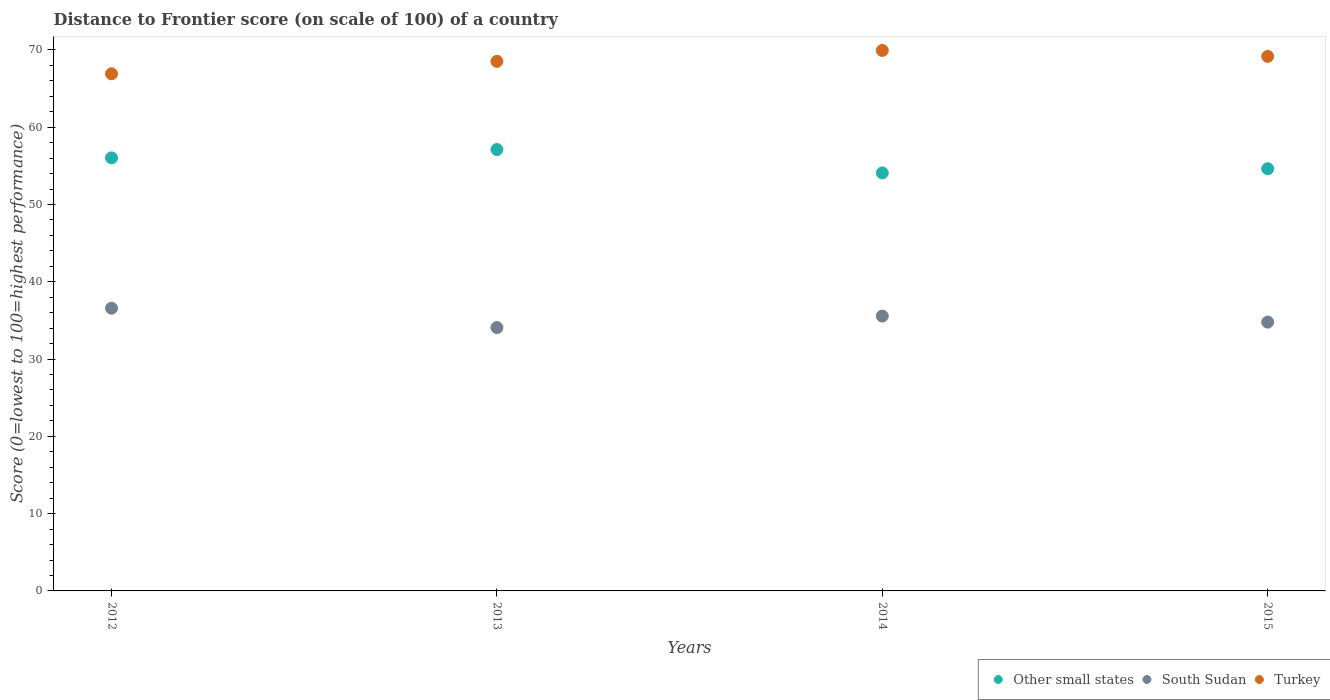How many different coloured dotlines are there?
Offer a very short reply. 3. What is the distance to frontier score of in Turkey in 2013?
Offer a very short reply. 68.52. Across all years, what is the maximum distance to frontier score of in South Sudan?
Your answer should be very brief. 36.58. Across all years, what is the minimum distance to frontier score of in South Sudan?
Your answer should be very brief. 34.07. In which year was the distance to frontier score of in South Sudan maximum?
Offer a terse response. 2012. In which year was the distance to frontier score of in Turkey minimum?
Provide a short and direct response. 2012. What is the total distance to frontier score of in South Sudan in the graph?
Give a very brief answer. 140.99. What is the difference between the distance to frontier score of in South Sudan in 2012 and that in 2014?
Give a very brief answer. 1.02. What is the difference between the distance to frontier score of in Turkey in 2015 and the distance to frontier score of in Other small states in 2014?
Make the answer very short. 15.08. What is the average distance to frontier score of in Other small states per year?
Ensure brevity in your answer.  55.46. In the year 2015, what is the difference between the distance to frontier score of in South Sudan and distance to frontier score of in Turkey?
Give a very brief answer. -34.38. In how many years, is the distance to frontier score of in Other small states greater than 52?
Your response must be concise. 4. What is the ratio of the distance to frontier score of in South Sudan in 2012 to that in 2013?
Offer a terse response. 1.07. Is the distance to frontier score of in South Sudan in 2013 less than that in 2014?
Your answer should be very brief. Yes. Is the difference between the distance to frontier score of in South Sudan in 2012 and 2014 greater than the difference between the distance to frontier score of in Turkey in 2012 and 2014?
Offer a terse response. Yes. What is the difference between the highest and the second highest distance to frontier score of in South Sudan?
Your answer should be compact. 1.02. What is the difference between the highest and the lowest distance to frontier score of in South Sudan?
Offer a terse response. 2.51. In how many years, is the distance to frontier score of in South Sudan greater than the average distance to frontier score of in South Sudan taken over all years?
Keep it short and to the point. 2. Is it the case that in every year, the sum of the distance to frontier score of in South Sudan and distance to frontier score of in Turkey  is greater than the distance to frontier score of in Other small states?
Keep it short and to the point. Yes. Is the distance to frontier score of in Other small states strictly less than the distance to frontier score of in South Sudan over the years?
Provide a succinct answer. No. How many dotlines are there?
Make the answer very short. 3. Does the graph contain any zero values?
Offer a terse response. No. Does the graph contain grids?
Make the answer very short. No. Where does the legend appear in the graph?
Provide a short and direct response. Bottom right. What is the title of the graph?
Provide a short and direct response. Distance to Frontier score (on scale of 100) of a country. What is the label or title of the X-axis?
Provide a succinct answer. Years. What is the label or title of the Y-axis?
Give a very brief answer. Score (0=lowest to 100=highest performance). What is the Score (0=lowest to 100=highest performance) in Other small states in 2012?
Provide a succinct answer. 56.03. What is the Score (0=lowest to 100=highest performance) in South Sudan in 2012?
Offer a terse response. 36.58. What is the Score (0=lowest to 100=highest performance) in Turkey in 2012?
Provide a succinct answer. 66.91. What is the Score (0=lowest to 100=highest performance) in Other small states in 2013?
Offer a terse response. 57.11. What is the Score (0=lowest to 100=highest performance) in South Sudan in 2013?
Give a very brief answer. 34.07. What is the Score (0=lowest to 100=highest performance) of Turkey in 2013?
Provide a short and direct response. 68.52. What is the Score (0=lowest to 100=highest performance) of Other small states in 2014?
Give a very brief answer. 54.08. What is the Score (0=lowest to 100=highest performance) of South Sudan in 2014?
Your response must be concise. 35.56. What is the Score (0=lowest to 100=highest performance) of Turkey in 2014?
Your answer should be very brief. 69.93. What is the Score (0=lowest to 100=highest performance) in Other small states in 2015?
Offer a terse response. 54.62. What is the Score (0=lowest to 100=highest performance) of South Sudan in 2015?
Offer a terse response. 34.78. What is the Score (0=lowest to 100=highest performance) in Turkey in 2015?
Your answer should be compact. 69.16. Across all years, what is the maximum Score (0=lowest to 100=highest performance) in Other small states?
Provide a succinct answer. 57.11. Across all years, what is the maximum Score (0=lowest to 100=highest performance) of South Sudan?
Your answer should be very brief. 36.58. Across all years, what is the maximum Score (0=lowest to 100=highest performance) of Turkey?
Keep it short and to the point. 69.93. Across all years, what is the minimum Score (0=lowest to 100=highest performance) in Other small states?
Keep it short and to the point. 54.08. Across all years, what is the minimum Score (0=lowest to 100=highest performance) in South Sudan?
Ensure brevity in your answer.  34.07. Across all years, what is the minimum Score (0=lowest to 100=highest performance) in Turkey?
Make the answer very short. 66.91. What is the total Score (0=lowest to 100=highest performance) in Other small states in the graph?
Provide a short and direct response. 221.85. What is the total Score (0=lowest to 100=highest performance) of South Sudan in the graph?
Your answer should be compact. 140.99. What is the total Score (0=lowest to 100=highest performance) of Turkey in the graph?
Offer a very short reply. 274.52. What is the difference between the Score (0=lowest to 100=highest performance) in Other small states in 2012 and that in 2013?
Provide a succinct answer. -1.08. What is the difference between the Score (0=lowest to 100=highest performance) of South Sudan in 2012 and that in 2013?
Ensure brevity in your answer.  2.51. What is the difference between the Score (0=lowest to 100=highest performance) of Turkey in 2012 and that in 2013?
Offer a very short reply. -1.61. What is the difference between the Score (0=lowest to 100=highest performance) of Other small states in 2012 and that in 2014?
Offer a terse response. 1.95. What is the difference between the Score (0=lowest to 100=highest performance) of Turkey in 2012 and that in 2014?
Provide a short and direct response. -3.02. What is the difference between the Score (0=lowest to 100=highest performance) of Other small states in 2012 and that in 2015?
Offer a terse response. 1.41. What is the difference between the Score (0=lowest to 100=highest performance) of South Sudan in 2012 and that in 2015?
Offer a very short reply. 1.8. What is the difference between the Score (0=lowest to 100=highest performance) in Turkey in 2012 and that in 2015?
Offer a terse response. -2.25. What is the difference between the Score (0=lowest to 100=highest performance) in Other small states in 2013 and that in 2014?
Make the answer very short. 3.03. What is the difference between the Score (0=lowest to 100=highest performance) in South Sudan in 2013 and that in 2014?
Make the answer very short. -1.49. What is the difference between the Score (0=lowest to 100=highest performance) of Turkey in 2013 and that in 2014?
Your answer should be very brief. -1.41. What is the difference between the Score (0=lowest to 100=highest performance) of Other small states in 2013 and that in 2015?
Ensure brevity in your answer.  2.49. What is the difference between the Score (0=lowest to 100=highest performance) of South Sudan in 2013 and that in 2015?
Make the answer very short. -0.71. What is the difference between the Score (0=lowest to 100=highest performance) in Turkey in 2013 and that in 2015?
Offer a terse response. -0.64. What is the difference between the Score (0=lowest to 100=highest performance) of Other small states in 2014 and that in 2015?
Provide a succinct answer. -0.54. What is the difference between the Score (0=lowest to 100=highest performance) of South Sudan in 2014 and that in 2015?
Offer a very short reply. 0.78. What is the difference between the Score (0=lowest to 100=highest performance) of Turkey in 2014 and that in 2015?
Offer a very short reply. 0.77. What is the difference between the Score (0=lowest to 100=highest performance) of Other small states in 2012 and the Score (0=lowest to 100=highest performance) of South Sudan in 2013?
Ensure brevity in your answer.  21.96. What is the difference between the Score (0=lowest to 100=highest performance) in Other small states in 2012 and the Score (0=lowest to 100=highest performance) in Turkey in 2013?
Provide a succinct answer. -12.49. What is the difference between the Score (0=lowest to 100=highest performance) in South Sudan in 2012 and the Score (0=lowest to 100=highest performance) in Turkey in 2013?
Provide a short and direct response. -31.94. What is the difference between the Score (0=lowest to 100=highest performance) in Other small states in 2012 and the Score (0=lowest to 100=highest performance) in South Sudan in 2014?
Provide a succinct answer. 20.47. What is the difference between the Score (0=lowest to 100=highest performance) of Other small states in 2012 and the Score (0=lowest to 100=highest performance) of Turkey in 2014?
Provide a short and direct response. -13.9. What is the difference between the Score (0=lowest to 100=highest performance) in South Sudan in 2012 and the Score (0=lowest to 100=highest performance) in Turkey in 2014?
Offer a very short reply. -33.35. What is the difference between the Score (0=lowest to 100=highest performance) in Other small states in 2012 and the Score (0=lowest to 100=highest performance) in South Sudan in 2015?
Keep it short and to the point. 21.25. What is the difference between the Score (0=lowest to 100=highest performance) in Other small states in 2012 and the Score (0=lowest to 100=highest performance) in Turkey in 2015?
Ensure brevity in your answer.  -13.13. What is the difference between the Score (0=lowest to 100=highest performance) of South Sudan in 2012 and the Score (0=lowest to 100=highest performance) of Turkey in 2015?
Ensure brevity in your answer.  -32.58. What is the difference between the Score (0=lowest to 100=highest performance) in Other small states in 2013 and the Score (0=lowest to 100=highest performance) in South Sudan in 2014?
Make the answer very short. 21.55. What is the difference between the Score (0=lowest to 100=highest performance) of Other small states in 2013 and the Score (0=lowest to 100=highest performance) of Turkey in 2014?
Provide a short and direct response. -12.82. What is the difference between the Score (0=lowest to 100=highest performance) of South Sudan in 2013 and the Score (0=lowest to 100=highest performance) of Turkey in 2014?
Ensure brevity in your answer.  -35.86. What is the difference between the Score (0=lowest to 100=highest performance) in Other small states in 2013 and the Score (0=lowest to 100=highest performance) in South Sudan in 2015?
Provide a succinct answer. 22.33. What is the difference between the Score (0=lowest to 100=highest performance) in Other small states in 2013 and the Score (0=lowest to 100=highest performance) in Turkey in 2015?
Your answer should be very brief. -12.05. What is the difference between the Score (0=lowest to 100=highest performance) in South Sudan in 2013 and the Score (0=lowest to 100=highest performance) in Turkey in 2015?
Make the answer very short. -35.09. What is the difference between the Score (0=lowest to 100=highest performance) of Other small states in 2014 and the Score (0=lowest to 100=highest performance) of South Sudan in 2015?
Provide a short and direct response. 19.3. What is the difference between the Score (0=lowest to 100=highest performance) of Other small states in 2014 and the Score (0=lowest to 100=highest performance) of Turkey in 2015?
Give a very brief answer. -15.08. What is the difference between the Score (0=lowest to 100=highest performance) of South Sudan in 2014 and the Score (0=lowest to 100=highest performance) of Turkey in 2015?
Offer a terse response. -33.6. What is the average Score (0=lowest to 100=highest performance) in Other small states per year?
Offer a very short reply. 55.46. What is the average Score (0=lowest to 100=highest performance) of South Sudan per year?
Offer a terse response. 35.25. What is the average Score (0=lowest to 100=highest performance) in Turkey per year?
Provide a succinct answer. 68.63. In the year 2012, what is the difference between the Score (0=lowest to 100=highest performance) in Other small states and Score (0=lowest to 100=highest performance) in South Sudan?
Keep it short and to the point. 19.45. In the year 2012, what is the difference between the Score (0=lowest to 100=highest performance) of Other small states and Score (0=lowest to 100=highest performance) of Turkey?
Your answer should be compact. -10.88. In the year 2012, what is the difference between the Score (0=lowest to 100=highest performance) of South Sudan and Score (0=lowest to 100=highest performance) of Turkey?
Your answer should be very brief. -30.33. In the year 2013, what is the difference between the Score (0=lowest to 100=highest performance) in Other small states and Score (0=lowest to 100=highest performance) in South Sudan?
Offer a terse response. 23.04. In the year 2013, what is the difference between the Score (0=lowest to 100=highest performance) in Other small states and Score (0=lowest to 100=highest performance) in Turkey?
Keep it short and to the point. -11.41. In the year 2013, what is the difference between the Score (0=lowest to 100=highest performance) of South Sudan and Score (0=lowest to 100=highest performance) of Turkey?
Your answer should be very brief. -34.45. In the year 2014, what is the difference between the Score (0=lowest to 100=highest performance) in Other small states and Score (0=lowest to 100=highest performance) in South Sudan?
Provide a succinct answer. 18.52. In the year 2014, what is the difference between the Score (0=lowest to 100=highest performance) in Other small states and Score (0=lowest to 100=highest performance) in Turkey?
Your response must be concise. -15.85. In the year 2014, what is the difference between the Score (0=lowest to 100=highest performance) in South Sudan and Score (0=lowest to 100=highest performance) in Turkey?
Keep it short and to the point. -34.37. In the year 2015, what is the difference between the Score (0=lowest to 100=highest performance) of Other small states and Score (0=lowest to 100=highest performance) of South Sudan?
Your answer should be compact. 19.84. In the year 2015, what is the difference between the Score (0=lowest to 100=highest performance) of Other small states and Score (0=lowest to 100=highest performance) of Turkey?
Offer a terse response. -14.54. In the year 2015, what is the difference between the Score (0=lowest to 100=highest performance) of South Sudan and Score (0=lowest to 100=highest performance) of Turkey?
Make the answer very short. -34.38. What is the ratio of the Score (0=lowest to 100=highest performance) of Other small states in 2012 to that in 2013?
Keep it short and to the point. 0.98. What is the ratio of the Score (0=lowest to 100=highest performance) in South Sudan in 2012 to that in 2013?
Offer a terse response. 1.07. What is the ratio of the Score (0=lowest to 100=highest performance) in Turkey in 2012 to that in 2013?
Provide a short and direct response. 0.98. What is the ratio of the Score (0=lowest to 100=highest performance) in Other small states in 2012 to that in 2014?
Provide a succinct answer. 1.04. What is the ratio of the Score (0=lowest to 100=highest performance) of South Sudan in 2012 to that in 2014?
Your answer should be very brief. 1.03. What is the ratio of the Score (0=lowest to 100=highest performance) of Turkey in 2012 to that in 2014?
Keep it short and to the point. 0.96. What is the ratio of the Score (0=lowest to 100=highest performance) in Other small states in 2012 to that in 2015?
Give a very brief answer. 1.03. What is the ratio of the Score (0=lowest to 100=highest performance) of South Sudan in 2012 to that in 2015?
Provide a short and direct response. 1.05. What is the ratio of the Score (0=lowest to 100=highest performance) in Turkey in 2012 to that in 2015?
Offer a terse response. 0.97. What is the ratio of the Score (0=lowest to 100=highest performance) of Other small states in 2013 to that in 2014?
Your answer should be very brief. 1.06. What is the ratio of the Score (0=lowest to 100=highest performance) of South Sudan in 2013 to that in 2014?
Your response must be concise. 0.96. What is the ratio of the Score (0=lowest to 100=highest performance) of Turkey in 2013 to that in 2014?
Your response must be concise. 0.98. What is the ratio of the Score (0=lowest to 100=highest performance) of Other small states in 2013 to that in 2015?
Provide a succinct answer. 1.05. What is the ratio of the Score (0=lowest to 100=highest performance) in South Sudan in 2013 to that in 2015?
Ensure brevity in your answer.  0.98. What is the ratio of the Score (0=lowest to 100=highest performance) in Other small states in 2014 to that in 2015?
Make the answer very short. 0.99. What is the ratio of the Score (0=lowest to 100=highest performance) of South Sudan in 2014 to that in 2015?
Your answer should be very brief. 1.02. What is the ratio of the Score (0=lowest to 100=highest performance) of Turkey in 2014 to that in 2015?
Make the answer very short. 1.01. What is the difference between the highest and the second highest Score (0=lowest to 100=highest performance) of Other small states?
Offer a terse response. 1.08. What is the difference between the highest and the second highest Score (0=lowest to 100=highest performance) in South Sudan?
Offer a very short reply. 1.02. What is the difference between the highest and the second highest Score (0=lowest to 100=highest performance) in Turkey?
Your answer should be very brief. 0.77. What is the difference between the highest and the lowest Score (0=lowest to 100=highest performance) in Other small states?
Give a very brief answer. 3.03. What is the difference between the highest and the lowest Score (0=lowest to 100=highest performance) in South Sudan?
Your answer should be very brief. 2.51. What is the difference between the highest and the lowest Score (0=lowest to 100=highest performance) of Turkey?
Give a very brief answer. 3.02. 